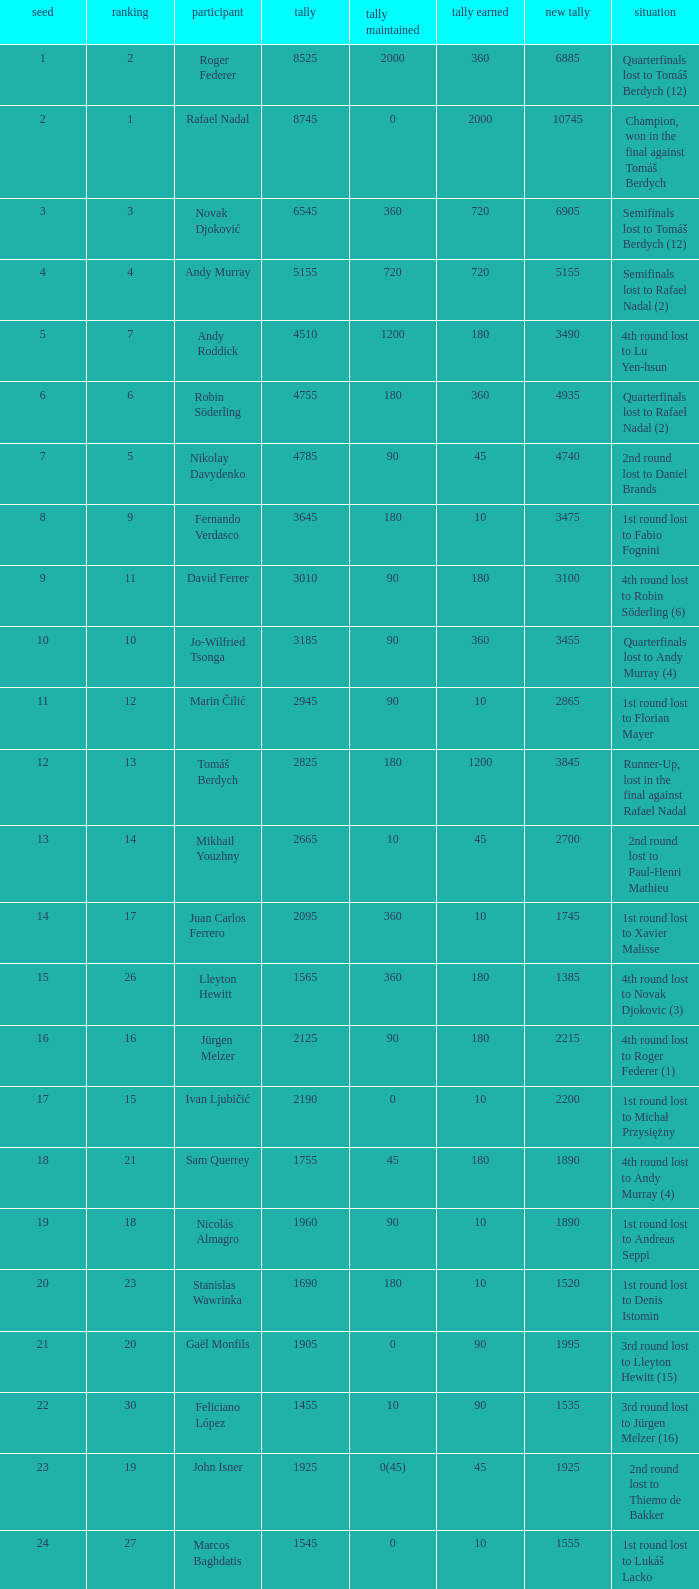Name the points won for 1230 90.0. 